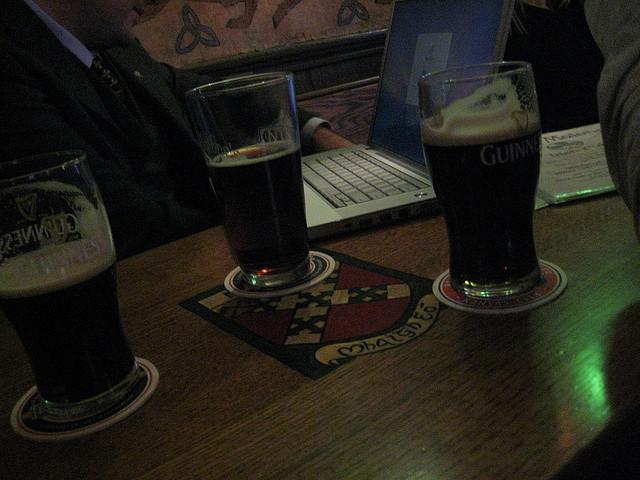How many glasses are there?
Give a very brief answer. 3. How many of these objects are not electronic?
Give a very brief answer. 3. How many cups are there?
Give a very brief answer. 3. How many people are visible?
Give a very brief answer. 2. How many bananas are pointed left?
Give a very brief answer. 0. 